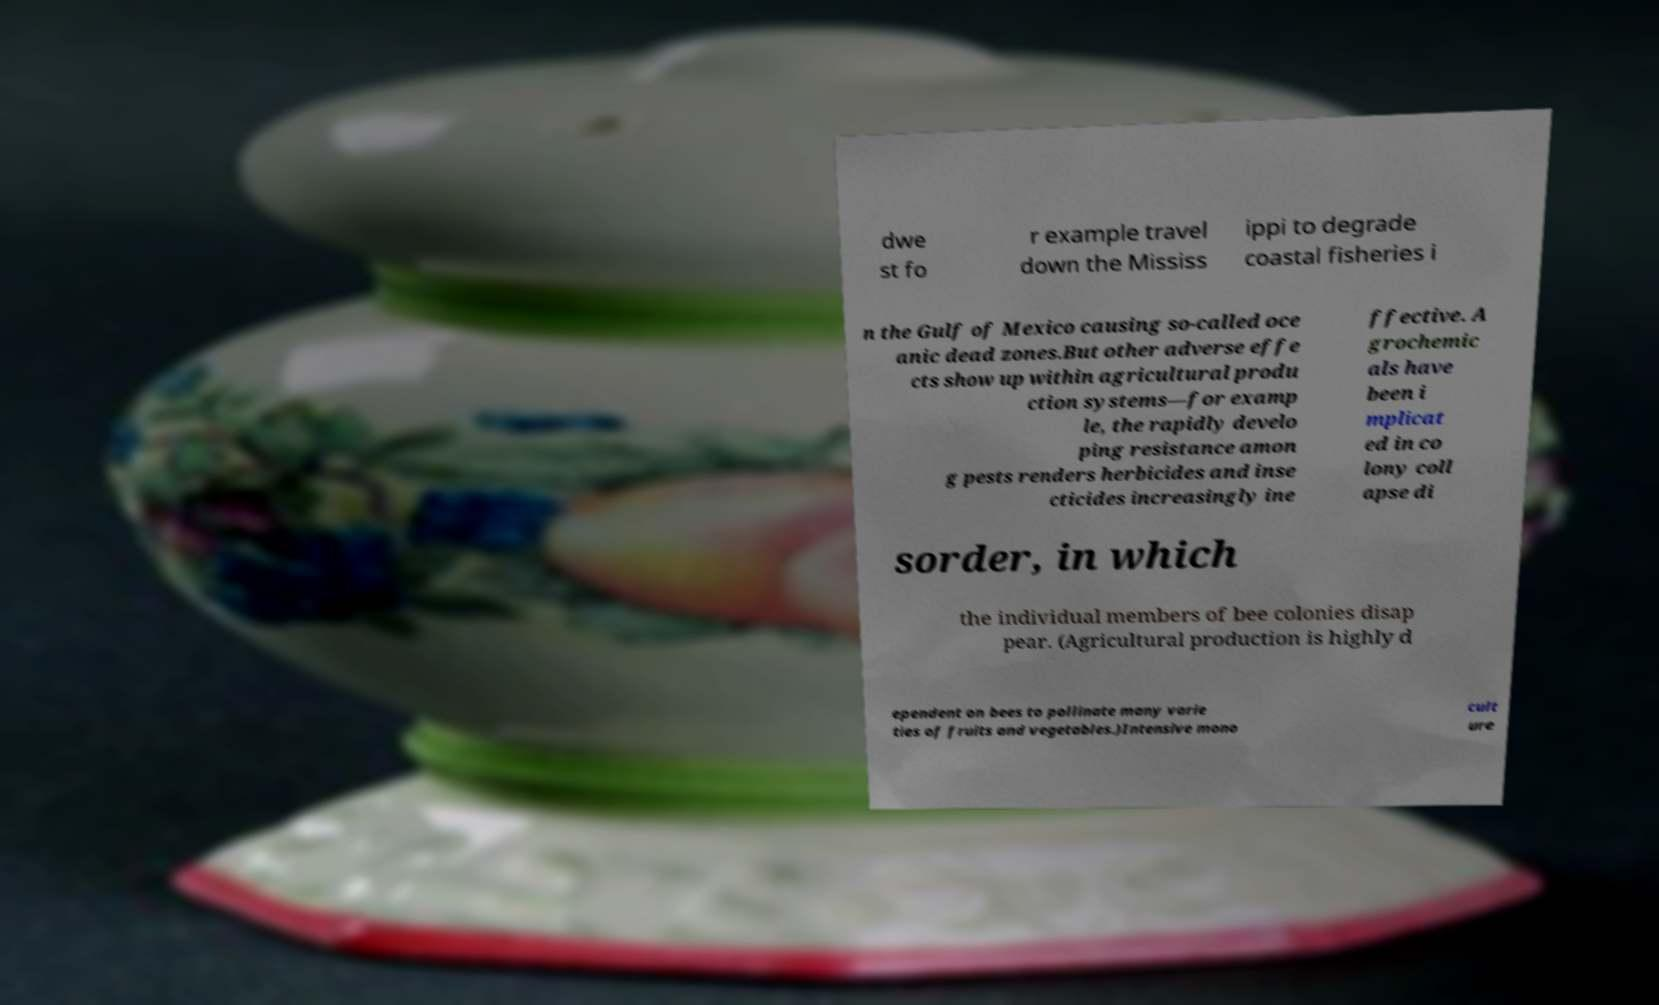Could you extract and type out the text from this image? dwe st fo r example travel down the Mississ ippi to degrade coastal fisheries i n the Gulf of Mexico causing so-called oce anic dead zones.But other adverse effe cts show up within agricultural produ ction systems—for examp le, the rapidly develo ping resistance amon g pests renders herbicides and inse cticides increasingly ine ffective. A grochemic als have been i mplicat ed in co lony coll apse di sorder, in which the individual members of bee colonies disap pear. (Agricultural production is highly d ependent on bees to pollinate many varie ties of fruits and vegetables.)Intensive mono cult ure 